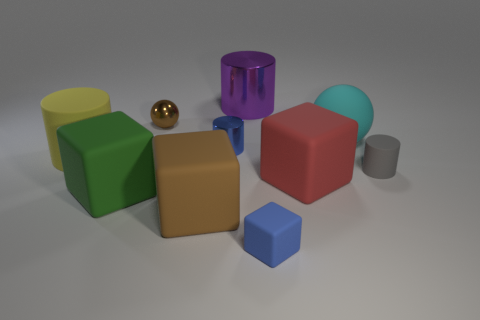There is a small blue object that is right of the purple metallic thing; does it have the same shape as the large red thing?
Provide a succinct answer. Yes. How many things are left of the tiny metal sphere and in front of the big red object?
Provide a succinct answer. 1. What material is the large purple object?
Keep it short and to the point. Metal. Is there any other thing of the same color as the big rubber sphere?
Provide a succinct answer. No. Do the small block and the big red thing have the same material?
Keep it short and to the point. Yes. What number of small blue cylinders are right of the metallic cylinder in front of the brown thing behind the large cyan thing?
Provide a succinct answer. 0. How many purple shiny cylinders are there?
Offer a very short reply. 1. Are there fewer cylinders on the right side of the large rubber cylinder than blue objects that are left of the big green block?
Offer a very short reply. No. Is the number of blue rubber objects left of the small blue cylinder less than the number of large purple cylinders?
Provide a succinct answer. Yes. What is the material of the ball to the right of the tiny matte object on the left side of the cylinder that is to the right of the red matte thing?
Your answer should be compact. Rubber. 